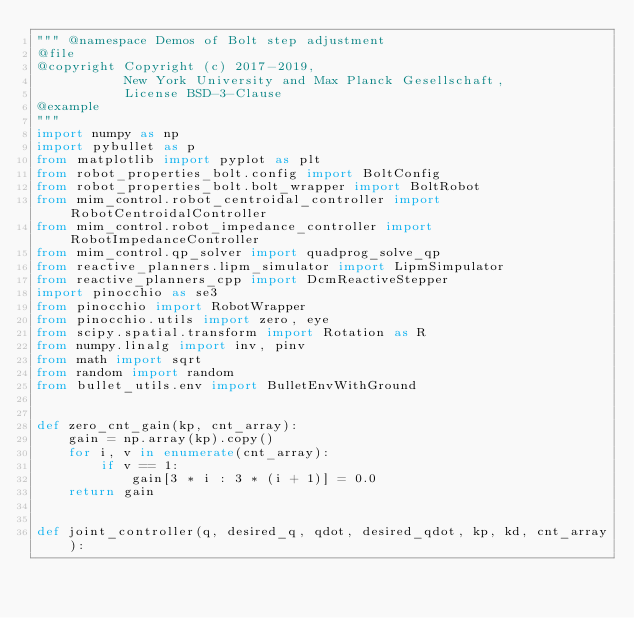<code> <loc_0><loc_0><loc_500><loc_500><_Python_>""" @namespace Demos of Bolt step adjustment
@file
@copyright Copyright (c) 2017-2019,
           New York University and Max Planck Gesellschaft,
           License BSD-3-Clause
@example
"""
import numpy as np
import pybullet as p
from matplotlib import pyplot as plt
from robot_properties_bolt.config import BoltConfig
from robot_properties_bolt.bolt_wrapper import BoltRobot
from mim_control.robot_centroidal_controller import RobotCentroidalController
from mim_control.robot_impedance_controller import RobotImpedanceController
from mim_control.qp_solver import quadprog_solve_qp
from reactive_planners.lipm_simulator import LipmSimpulator
from reactive_planners_cpp import DcmReactiveStepper
import pinocchio as se3
from pinocchio import RobotWrapper
from pinocchio.utils import zero, eye
from scipy.spatial.transform import Rotation as R
from numpy.linalg import inv, pinv
from math import sqrt
from random import random
from bullet_utils.env import BulletEnvWithGround


def zero_cnt_gain(kp, cnt_array):
    gain = np.array(kp).copy()
    for i, v in enumerate(cnt_array):
        if v == 1:
            gain[3 * i : 3 * (i + 1)] = 0.0
    return gain


def joint_controller(q, desired_q, qdot, desired_qdot, kp, kd, cnt_array):</code> 